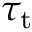Convert formula to latex. <formula><loc_0><loc_0><loc_500><loc_500>\tau _ { t }</formula> 